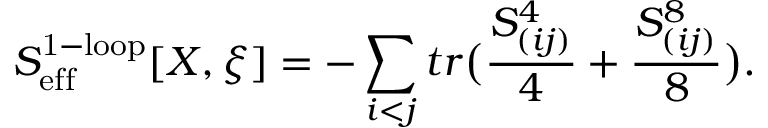<formula> <loc_0><loc_0><loc_500><loc_500>S _ { e f f } ^ { 1 - l o o p } [ X , \xi ] = - \sum _ { i < j } t r \left ( \frac { S _ { ( i j ) } ^ { 4 } } { 4 } + \frac { S _ { ( i j ) } ^ { 8 } } { 8 } \right ) .</formula> 